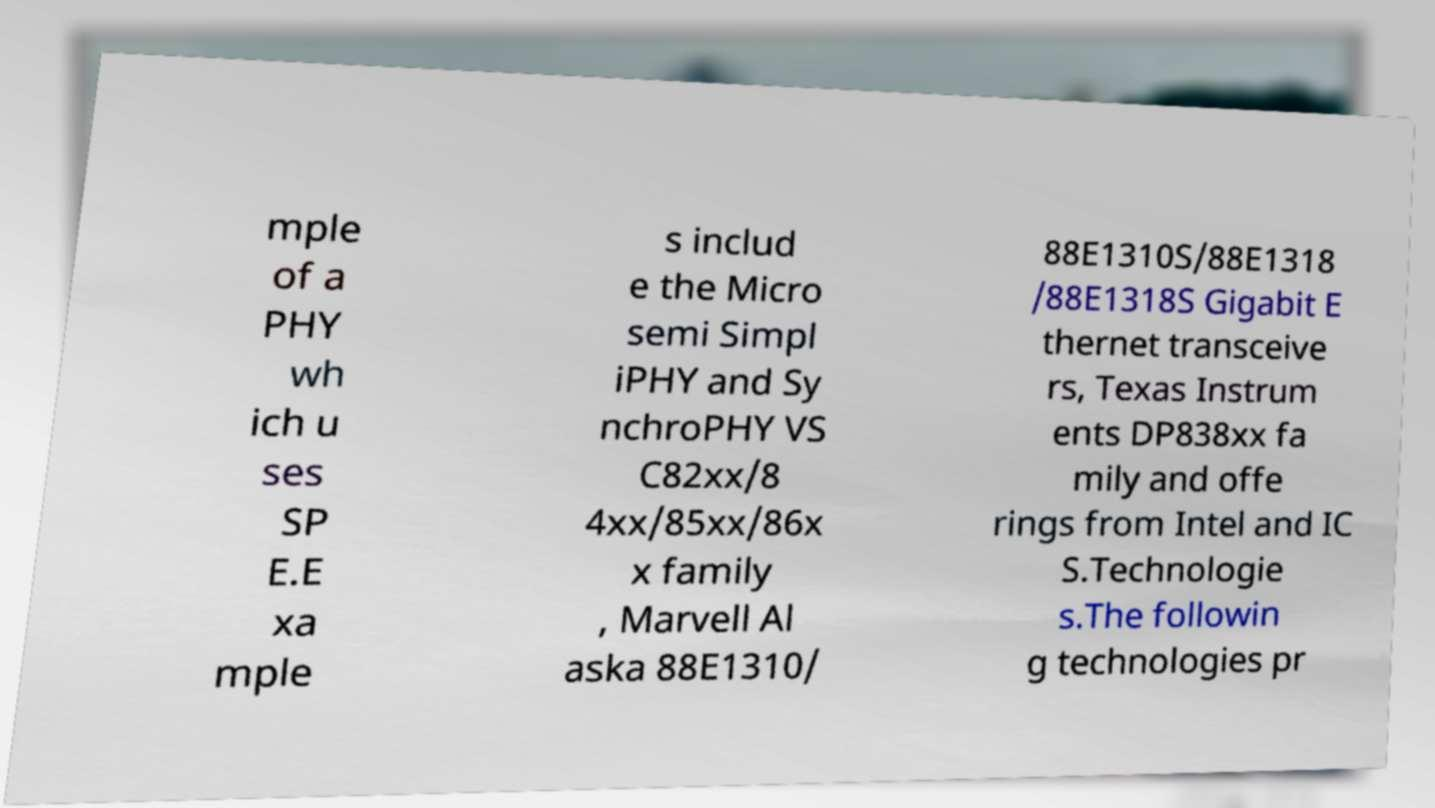I need the written content from this picture converted into text. Can you do that? mple of a PHY wh ich u ses SP E.E xa mple s includ e the Micro semi Simpl iPHY and Sy nchroPHY VS C82xx/8 4xx/85xx/86x x family , Marvell Al aska 88E1310/ 88E1310S/88E1318 /88E1318S Gigabit E thernet transceive rs, Texas Instrum ents DP838xx fa mily and offe rings from Intel and IC S.Technologie s.The followin g technologies pr 